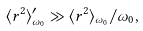Convert formula to latex. <formula><loc_0><loc_0><loc_500><loc_500>\langle r ^ { 2 } \rangle ^ { \prime } _ { \omega _ { 0 } } \gg \langle r ^ { 2 } \rangle _ { \omega _ { 0 } } / \omega _ { 0 } ,</formula> 